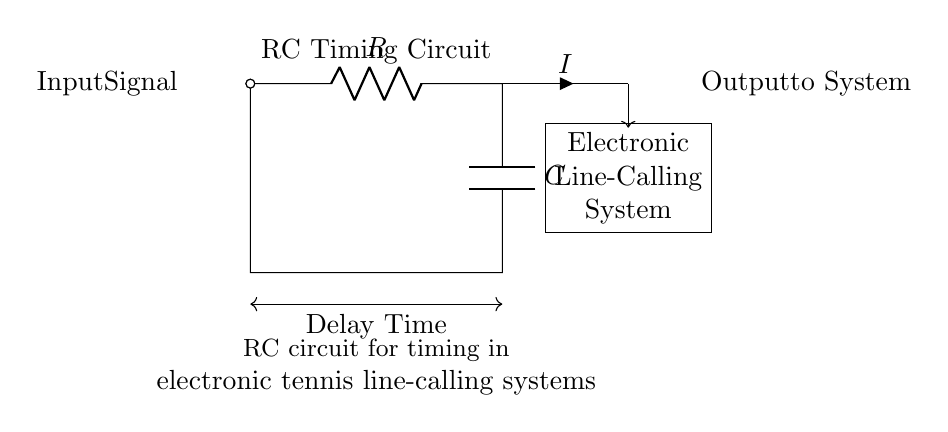What components are in the circuit? The circuit contains a resistor and a capacitor, which are the main components used in RC timing circuits. They are represented by the symbols near the left and center bottom of the diagram.
Answer: Resistor and Capacitor What does the 'I' represent in this circuit? The 'I' symbol indicates the current flowing through the circuit, specifically through the resistor and capacitor. It is located near the connection where the resistor meets the capacitor.
Answer: Current What is the function of this RC circuit? The primary function of this RC circuit is to provide timing in electronic tennis line-calling systems, helping determine the timing of the output signal based on the charging and discharging of the capacitor.
Answer: Timing in line-calling systems How can you describe the connection between the resistor and capacitor? The resistor and capacitor are connected in series, meaning the current flows through the resistor first, and then the capacitor receives this current to charge. This series connection affects the timing behavior of the circuit.
Answer: Series connection What is the significance of the 'Delay Time'? 'Delay Time' indicates the amount of time the circuit takes to respond to an input signal, which is determined by the values of the resistor and capacitor according to the time constant formula. This is crucial for the timing application in the line-calling system.
Answer: Time constant What does the 'Output to System' signify in this context? 'Output to System' refers to the processed signal that the electronic line-calling system receives after the timing mechanism, enabling it to determine the outcome of a line call in tennis. This output is affected by the RC timing characteristics of the circuit.
Answer: Processed signal for line-calling 